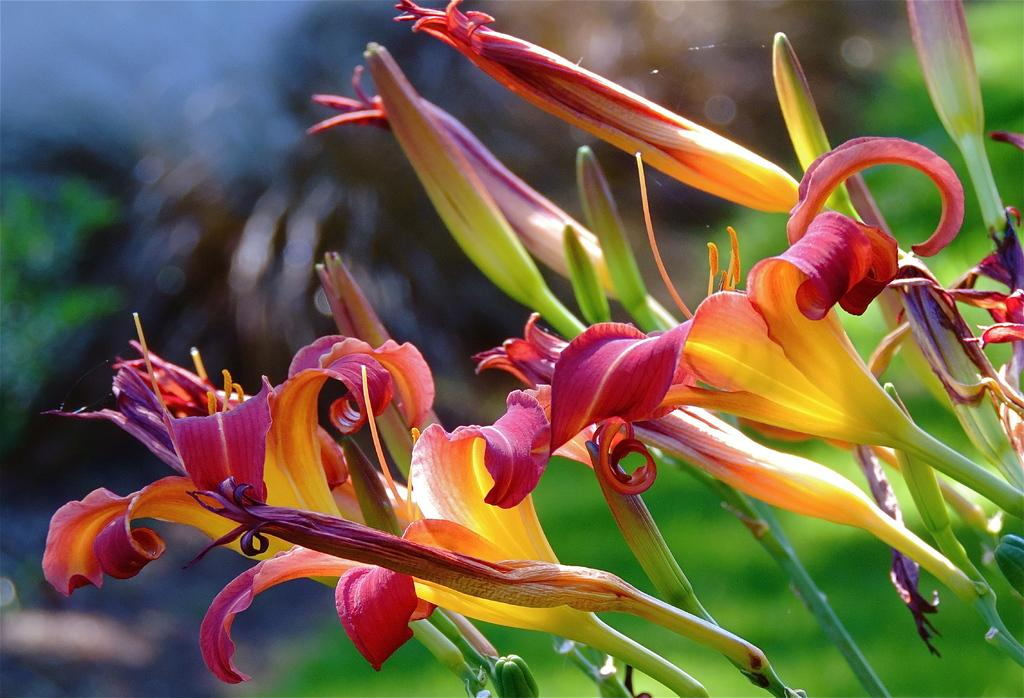What is the location of the image in relation to the city? The image is taken from outside the city. What type of vegetation can be seen on the right side of the image? There are plants with flowers on the right side of the image. What colors are present in the background of the image? The background of the image includes black and green colors. What type of class is being held in the image? There is no class present in the image. What emotion is being displayed by the plants in the image? Plants do not display emotions, so this question cannot be answered. 